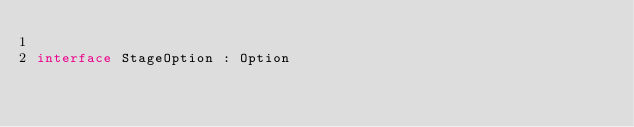<code> <loc_0><loc_0><loc_500><loc_500><_Kotlin_>
interface StageOption : Option
</code> 